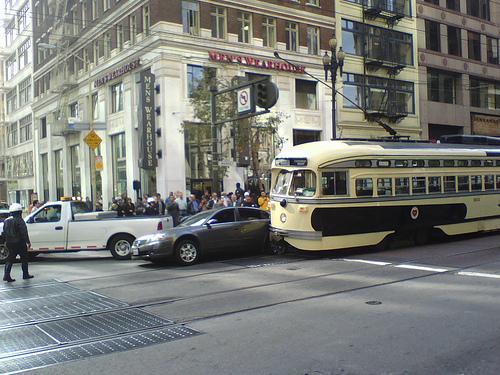How many white trucks are in the picture?
Give a very brief answer. 1. 